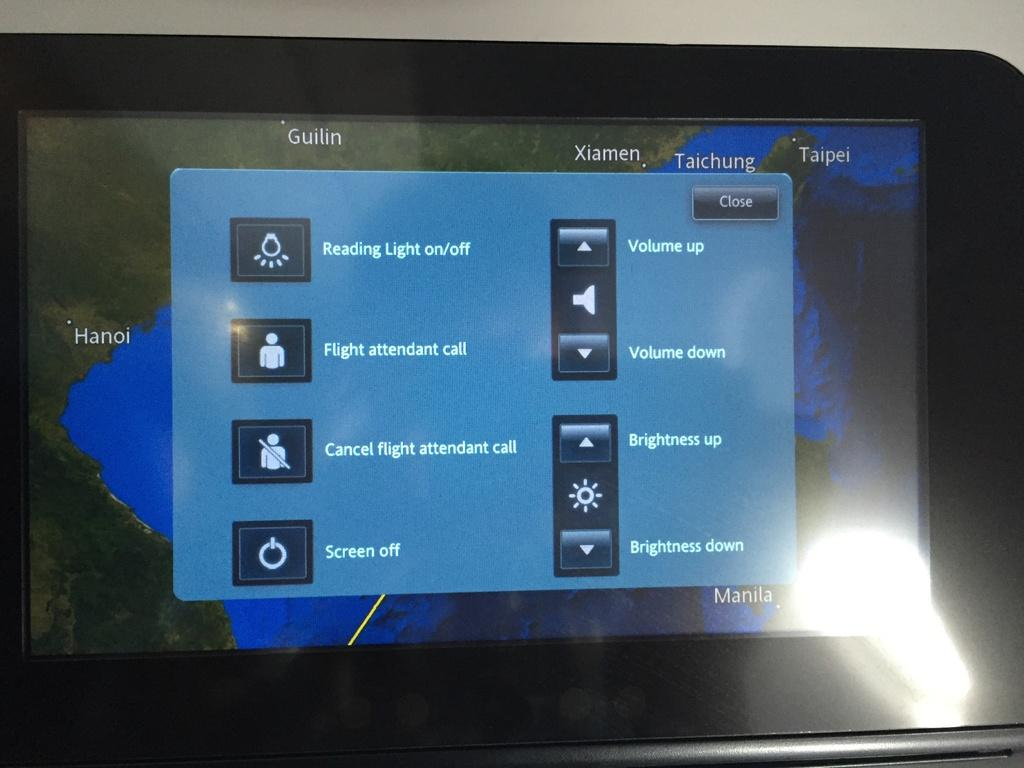What is the main object in the image? There is a black color tab in the image. What feature does the tab have? The tab has a screen. What can be seen on the screen? There is a menu visible on the screen. Where is the flashlight located in the image? The flashlight is in the right side bottom corner of the image. What is the color of the background in the image? The background is white in color. How many teeth can be seen on the tab in the image? There are no teeth visible on the tab in the image. Are there any tomatoes being sliced on the screen? There are no tomatoes or any indication of slicing in the image. 